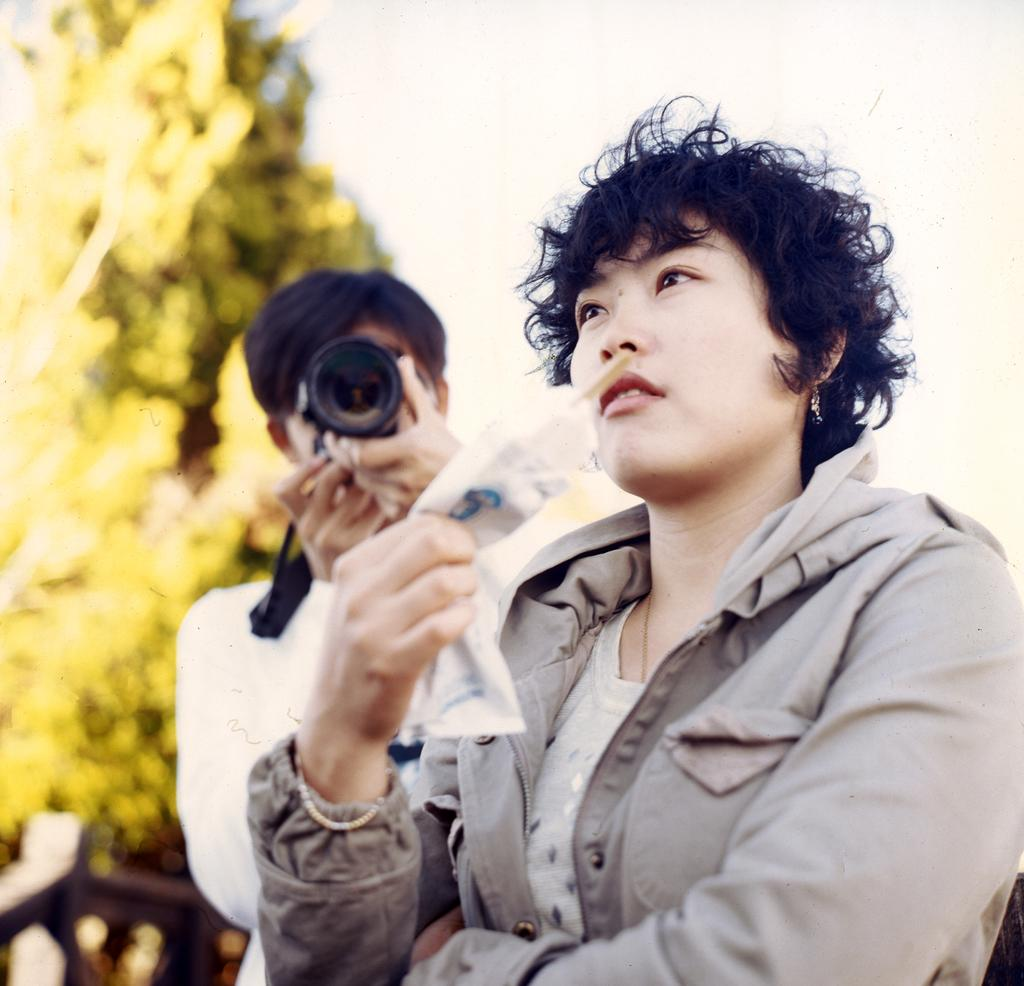Who is the main subject in the image? There is a woman in the image. What is the woman holding in the image? The woman is holding an object. Can you describe the person behind the woman? The person behind the woman is holding a camera. What is the person behind the woman doing? The person behind the woman is taking a picture. Why is the toothbrush crying in the image? There is no toothbrush present in the image, and therefore no such activity can be observed. 